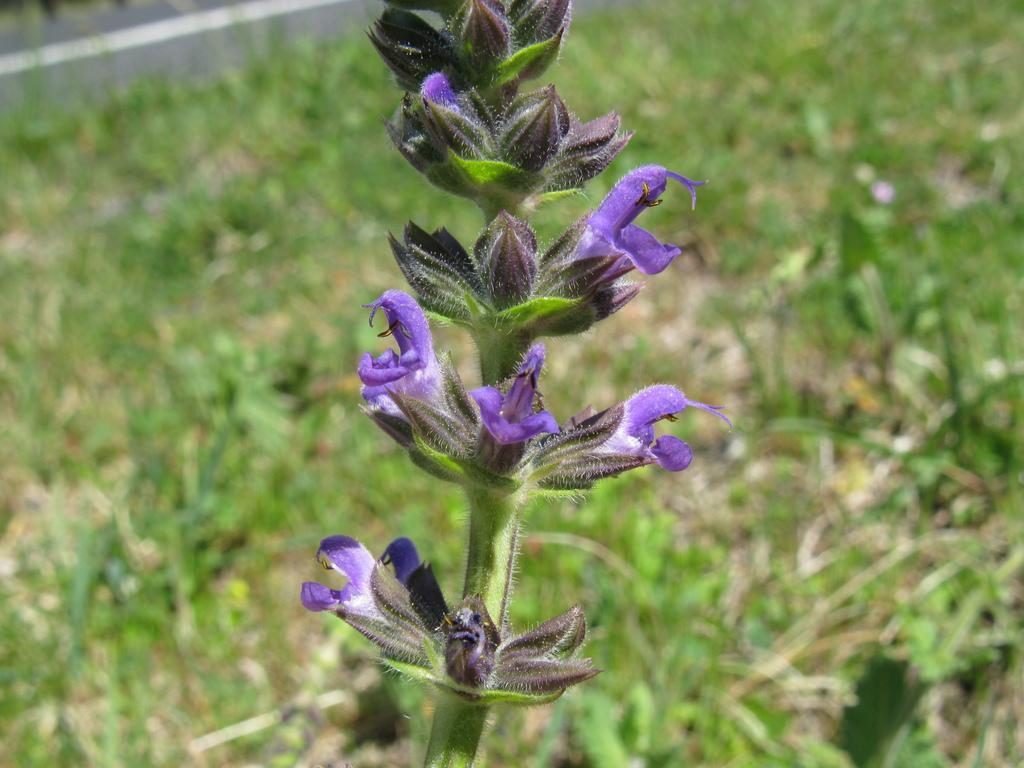What type of plant is featured in the image? There is English lavender in the image. Can you describe the background of the image? The background of the image is blurred. Can you see a rat hiding among the English lavender in the image? There is no rat present in the image; it only features English lavender. What direction is the fan facing in the image? There is no fan present in the image. 